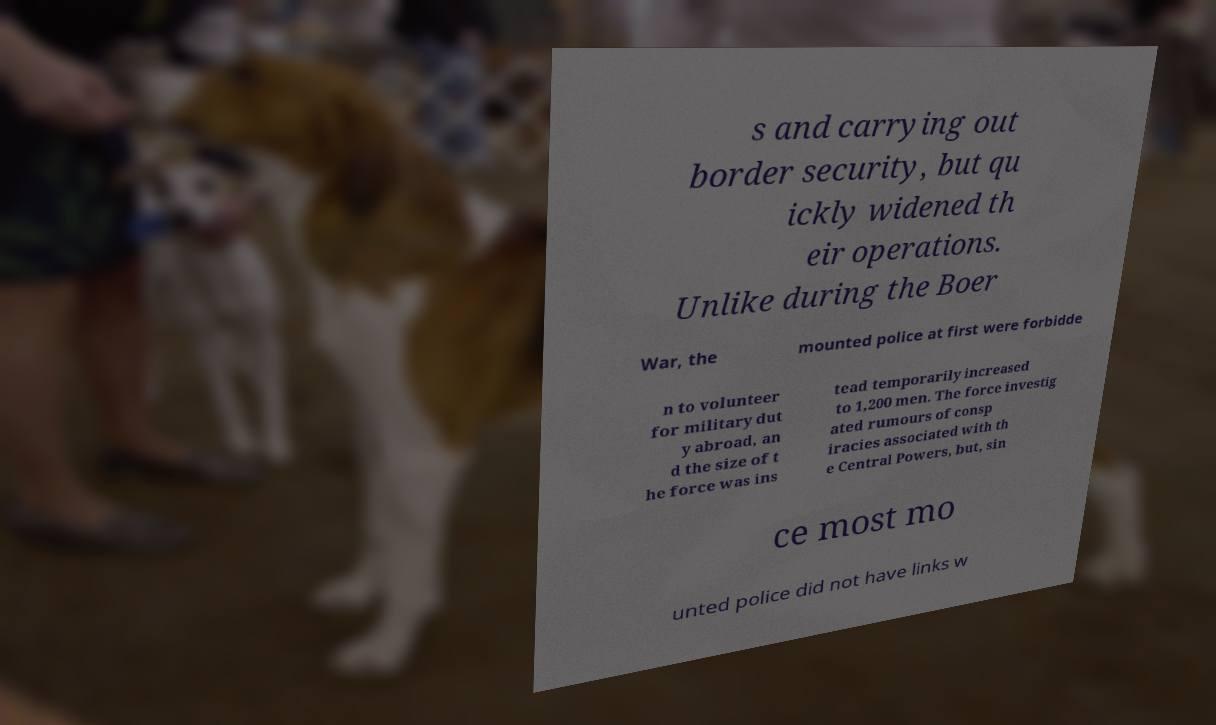Could you assist in decoding the text presented in this image and type it out clearly? s and carrying out border security, but qu ickly widened th eir operations. Unlike during the Boer War, the mounted police at first were forbidde n to volunteer for military dut y abroad, an d the size of t he force was ins tead temporarily increased to 1,200 men. The force investig ated rumours of consp iracies associated with th e Central Powers, but, sin ce most mo unted police did not have links w 